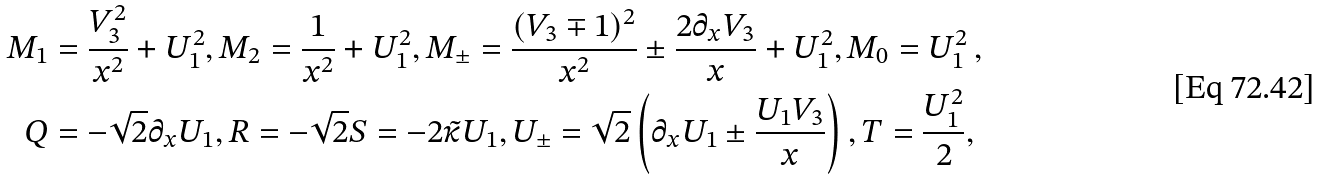Convert formula to latex. <formula><loc_0><loc_0><loc_500><loc_500>M _ { 1 } & = \frac { V _ { 3 } ^ { 2 } } { x ^ { 2 } } + U _ { 1 } ^ { 2 } , M _ { 2 } = \frac { 1 } { x ^ { 2 } } + U _ { 1 } ^ { 2 } , M _ { \pm } = \frac { ( V _ { 3 } \mp 1 ) ^ { 2 } } { x ^ { 2 } } \pm \frac { 2 \partial _ { x } V _ { 3 } } { x } + U _ { 1 } ^ { 2 } , M _ { 0 } = U _ { 1 } ^ { 2 } \, , \\ Q & = - \sqrt { 2 } \partial _ { x } U _ { 1 } , R = - \sqrt { 2 } S = - 2 { \tilde { \kappa } } U _ { 1 } , U _ { \pm } = \sqrt { 2 } \left ( \partial _ { x } U _ { 1 } \pm \frac { U _ { 1 } V _ { 3 } } { x } \right ) , T = \frac { U _ { 1 } ^ { 2 } } { 2 } ,</formula> 